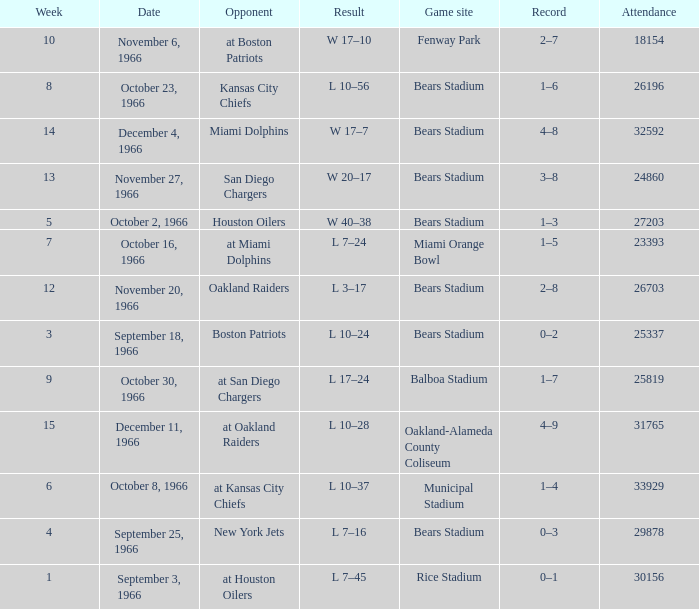What was the date of the game when the opponent was the Miami Dolphins? December 4, 1966. 